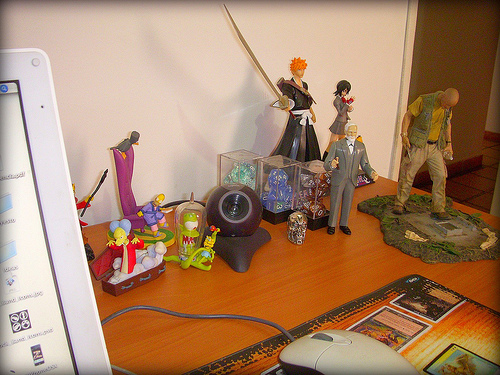<image>
Is there a old man on the table? Yes. Looking at the image, I can see the old man is positioned on top of the table, with the table providing support. Where is the male figure in relation to the woman figure? Is it in front of the woman figure? Yes. The male figure is positioned in front of the woman figure, appearing closer to the camera viewpoint. 